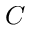Convert formula to latex. <formula><loc_0><loc_0><loc_500><loc_500>C</formula> 